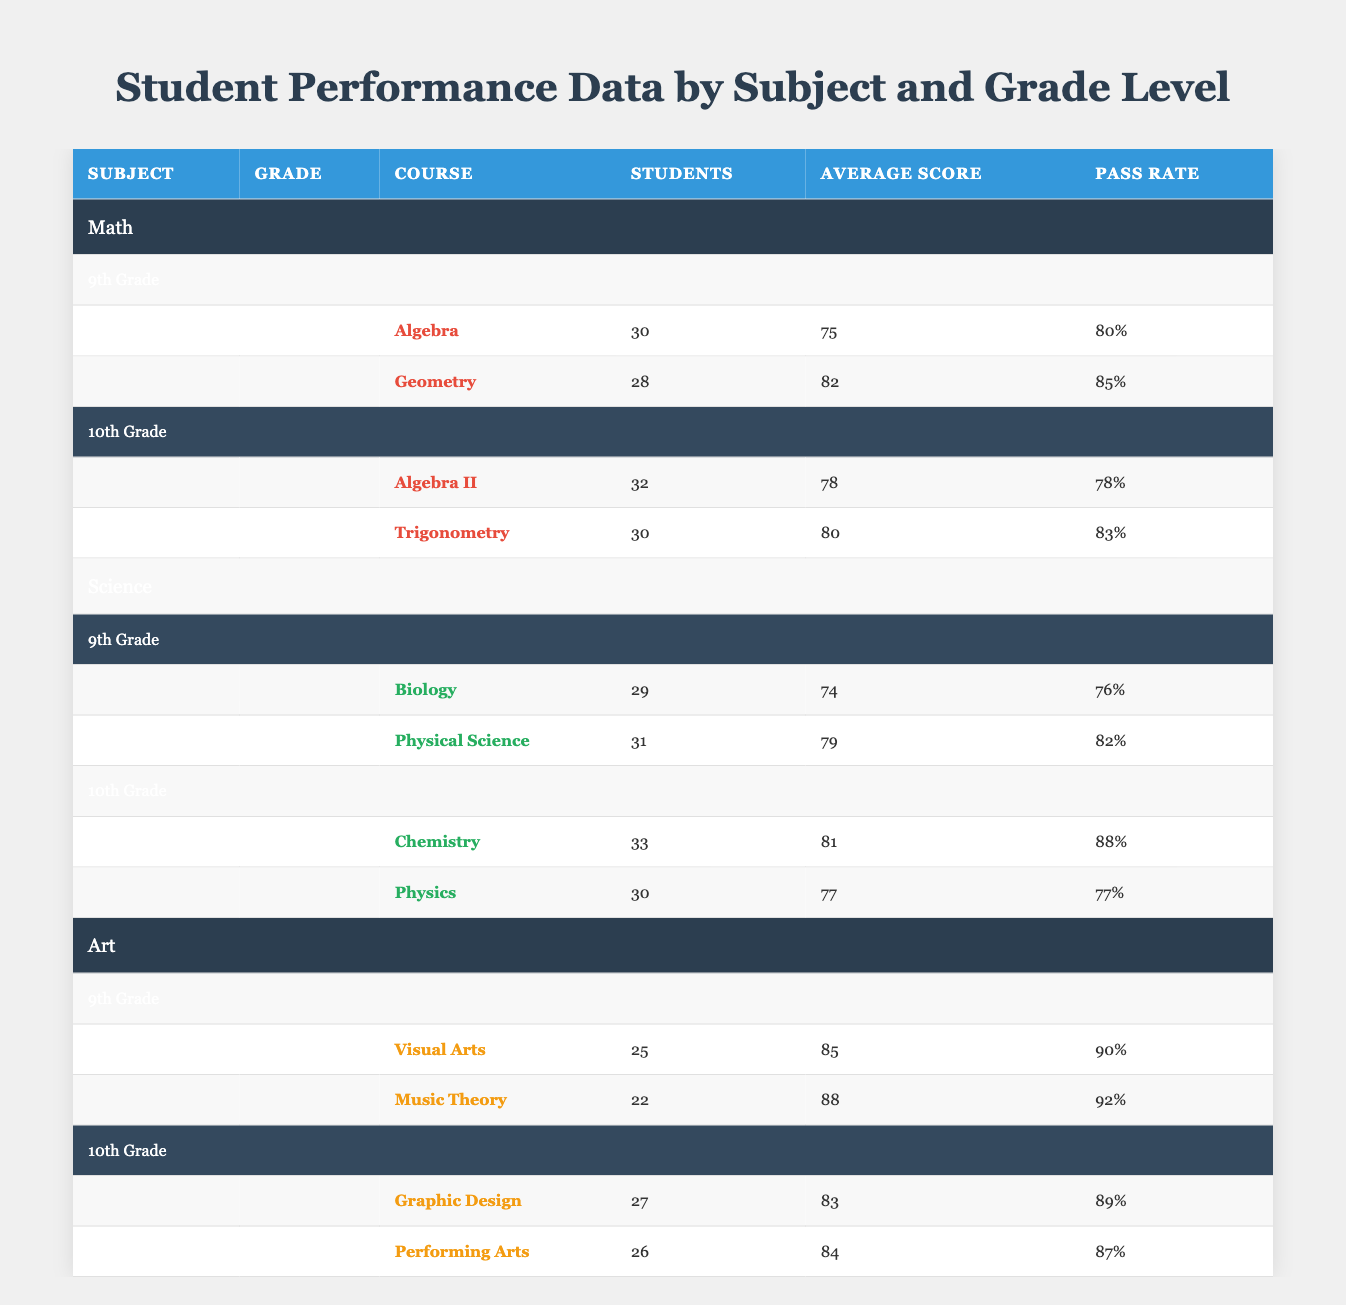What is the average score of Algebra in 9th Grade? The table shows that the average score for Algebra in 9th Grade is 75.
Answer: 75 What is the pass rate for Chemistry in 10th Grade? The table indicates that the pass rate for Chemistry in 10th Grade is 88%.
Answer: 88% How many students took Physical Science in 9th Grade? According to the table, the number of students who took Physical Science in 9th Grade is 31.
Answer: 31 What is the difference in average scores between Music Theory and Performing Arts? Music Theory averages 88 while Performing Arts averages 84. The difference is 88 - 84 = 4.
Answer: 4 Which subject and grade level has the highest pass rate? Looking through the table, Art in 9th Grade, Music Theory specifically, has the highest pass rate of 92%.
Answer: Art in 9th Grade Is the average score for Trigonometry higher than that of Algebra II? The average score for Trigonometry is 80 while for Algebra II it is 78, so yes, Trigonometry is higher.
Answer: Yes Calculate the total number of students across all courses in 10th Grade. In 10th Grade, the students are: Algebra II (32), Trigonometry (30), Chemistry (33), and Physics (30). The total is 32 + 30 + 33 + 30 = 125.
Answer: 125 Does any subject in 9th Grade have an average score below 75? The average scores in 9th Grade are as follows: Algebra (75), Biology (74), Visual Arts (85), and Music Theory (88). Biology is below 75.
Answer: Yes What is the average score of the courses in 10th Grade for Science? The 10th Grade Science courses are Chemistry (81) and Physics (77). Their average is (81 + 77) / 2 = 79.
Answer: 79 